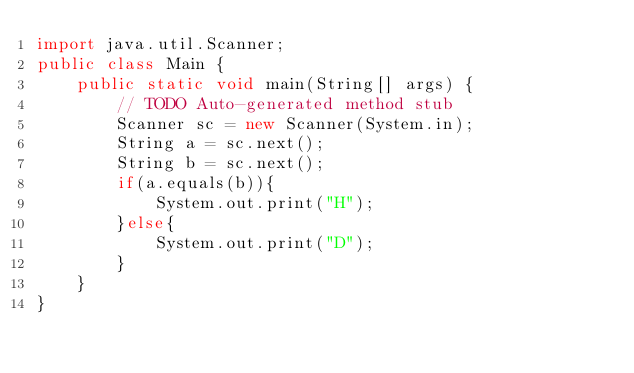<code> <loc_0><loc_0><loc_500><loc_500><_Java_>import java.util.Scanner;
public class Main {
	public static void main(String[] args) {
		// TODO Auto-generated method stub
		Scanner sc = new Scanner(System.in);
		String a = sc.next();
		String b = sc.next();
		if(a.equals(b)){
			System.out.print("H");
		}else{
			System.out.print("D");
		}
	}
}</code> 